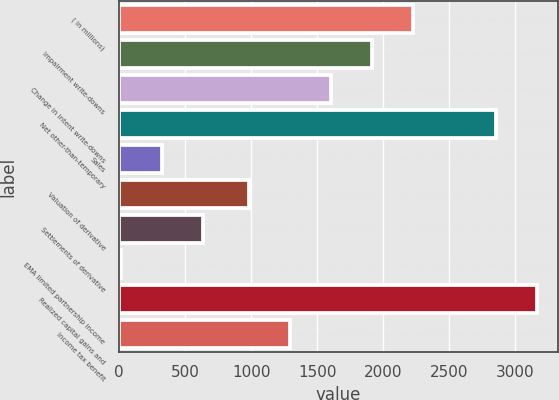<chart> <loc_0><loc_0><loc_500><loc_500><bar_chart><fcel>( in millions)<fcel>Impairment write-downs<fcel>Change in intent write-downs<fcel>Net other-than-temporary<fcel>Sales<fcel>Valuation of derivative<fcel>Settlements of derivative<fcel>EMA limited partnership income<fcel>Realized capital gains and<fcel>Income tax benefit<nl><fcel>2230.2<fcel>1918.9<fcel>1607.6<fcel>2852.8<fcel>325.3<fcel>985<fcel>636.6<fcel>14<fcel>3164.1<fcel>1296.3<nl></chart> 